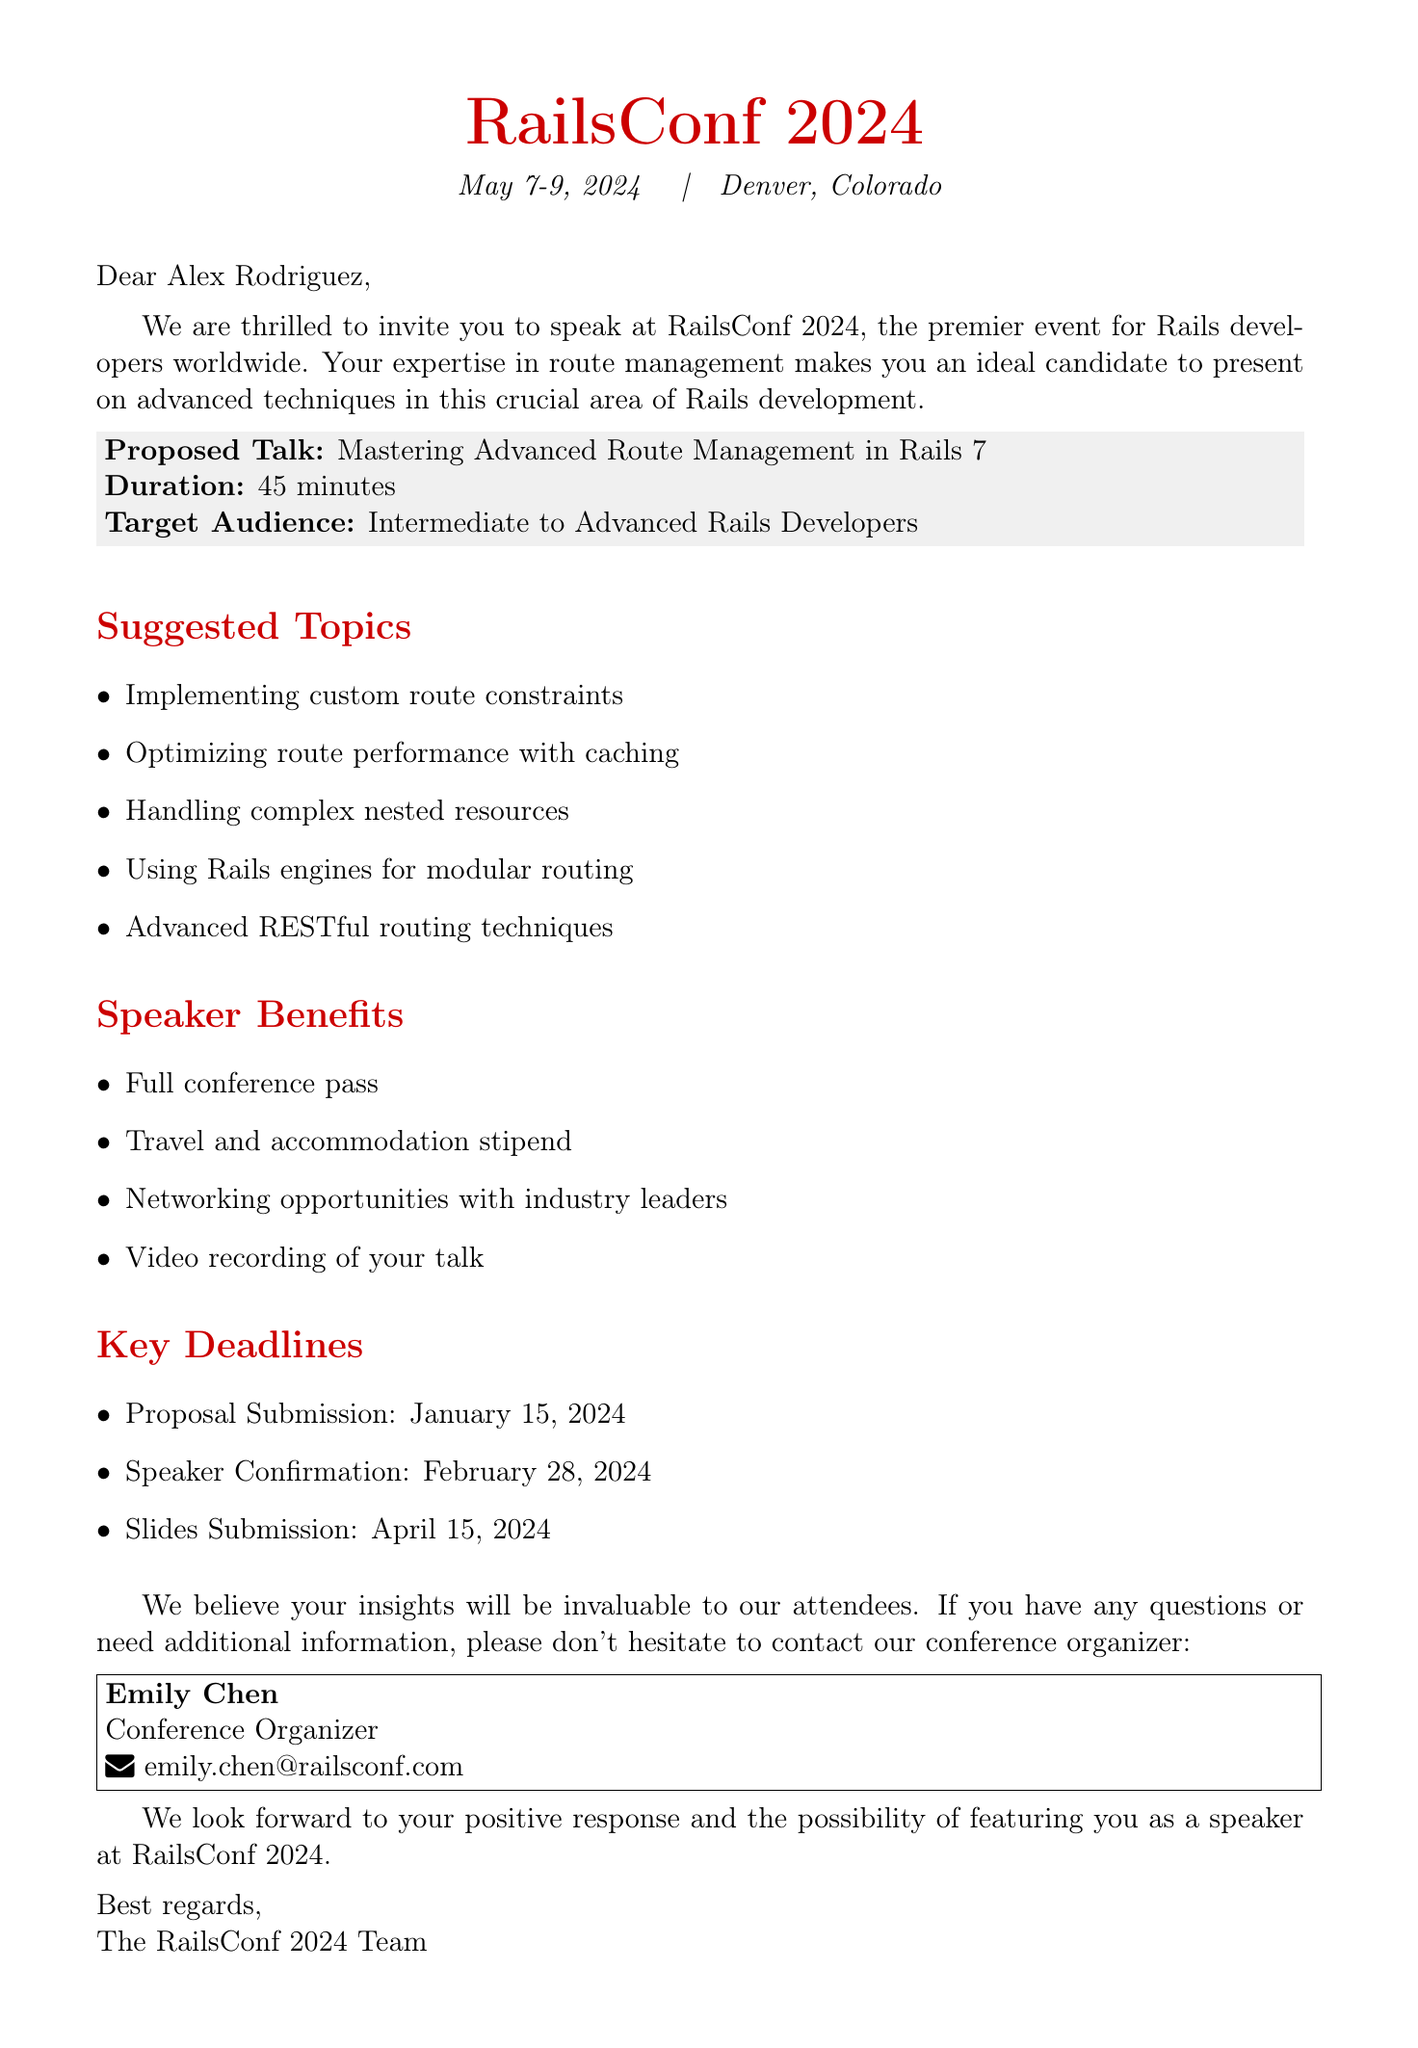What is the name of the conference? The conference is referred to as RailsConf 2024 in the document.
Answer: RailsConf 2024 Who is the invited speaker? The document identifies "Alex Rodriguez" as the speaker being invited.
Answer: Alex Rodriguez What is the duration of the proposed talk? The duration specified for the talk is 45 minutes.
Answer: 45 minutes What is the target audience for the talk? According to the document, the talk is aimed at "Intermediate to Advanced Rails Developers."
Answer: Intermediate to Advanced Rails Developers When is the proposal submission deadline? The timeline indicates the proposal submission deadline is January 15, 2024.
Answer: January 15, 2024 What are some suggested topics for the talk? The document lists five suggested topics, including "Implementing custom route constraints."
Answer: Implementing custom route constraints What benefits does the speaker receive? The document outlines several benefits, including a "Full conference pass."
Answer: Full conference pass What is the location of the conference? The document states that the conference will take place in Denver, Colorado.
Answer: Denver, Colorado Who should be contacted for more information? The document lists "Emily Chen" as the contact person for inquiries.
Answer: Emily Chen 